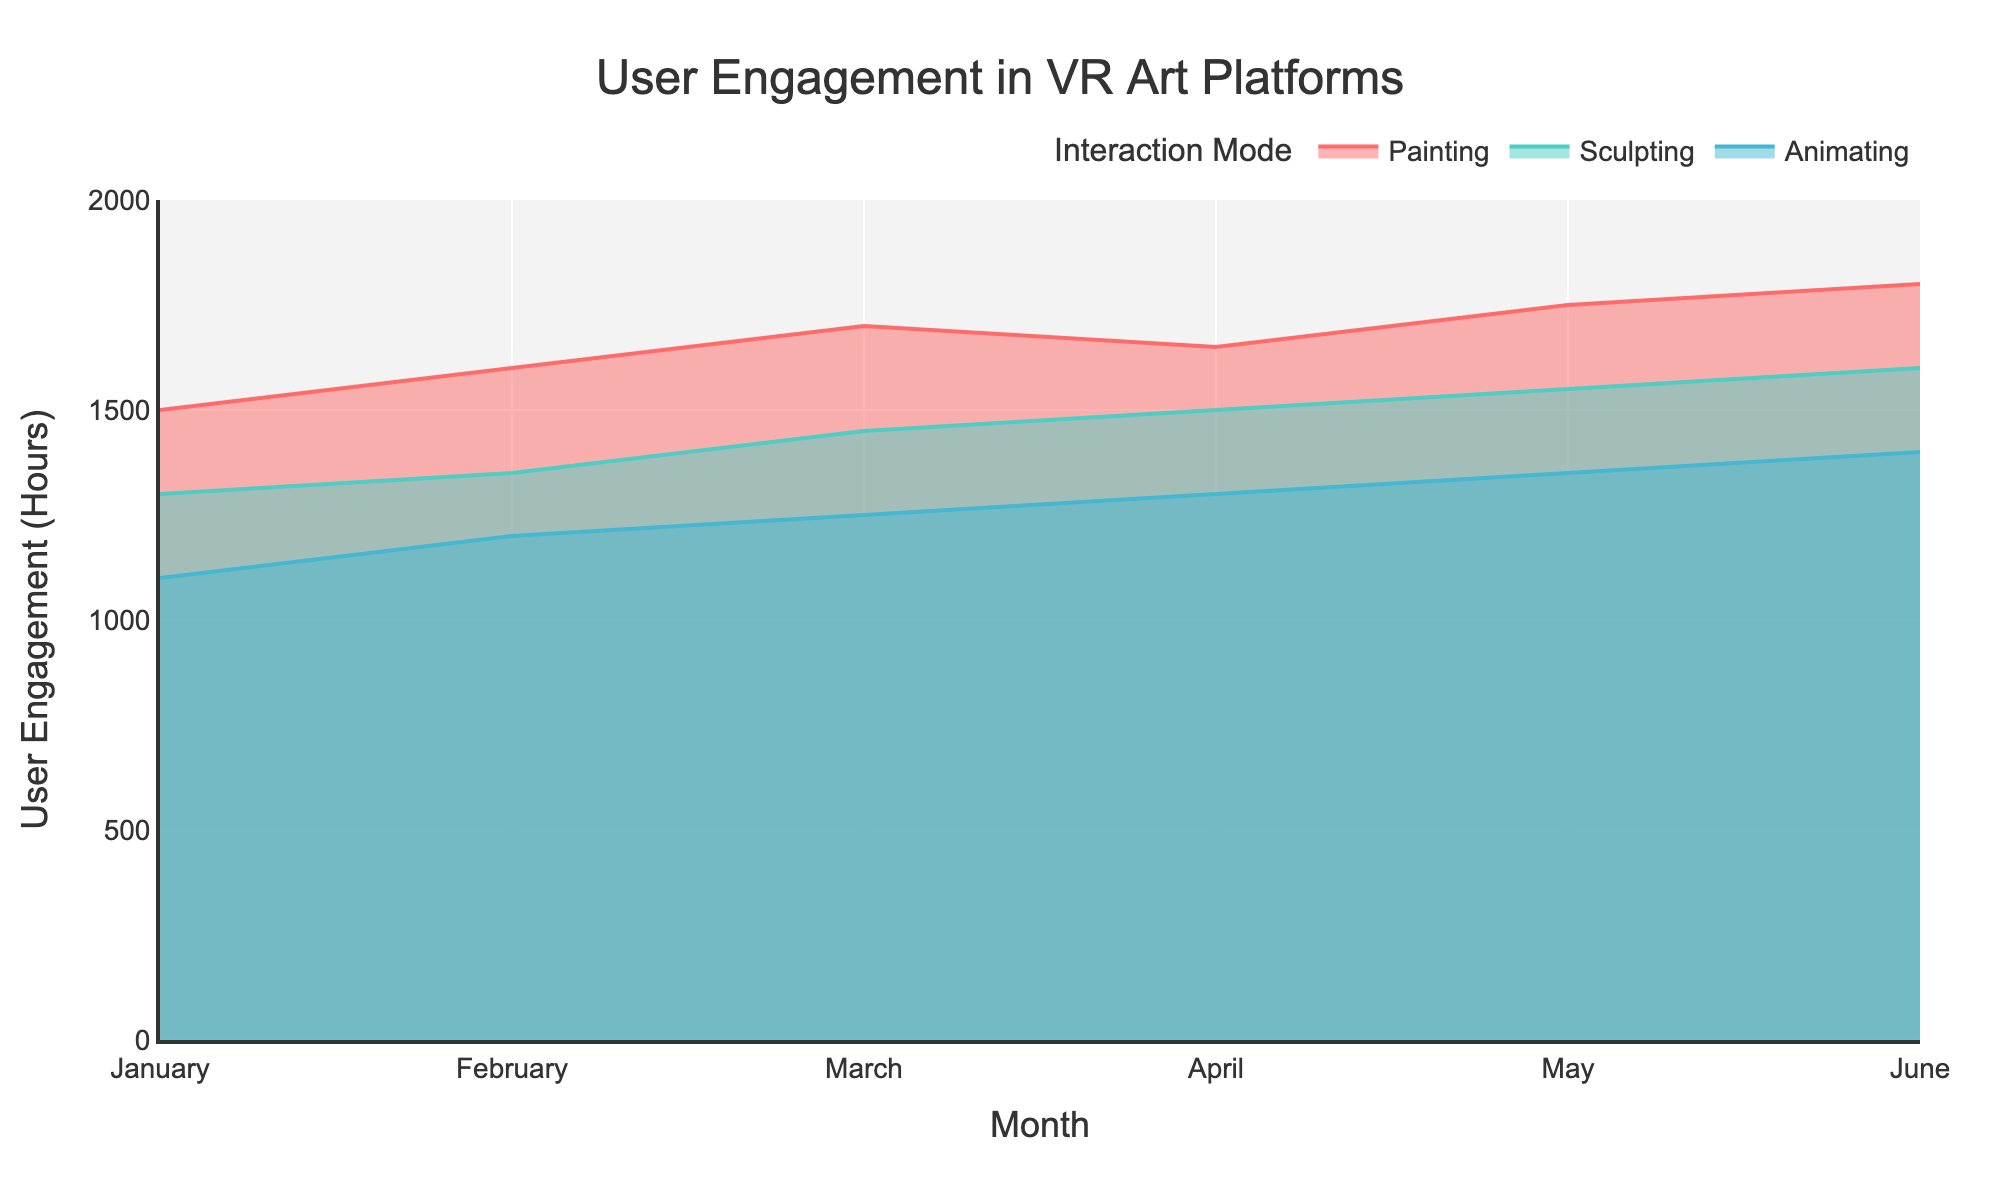What's the title of the chart? The title of the chart is displayed at the top and reads "User Engagement in VR Art Platforms".
Answer: User Engagement in VR Art Platforms How does the user engagement in painting change over the months? By observing the area chart, the user engagement in painting starts at 1500 hours in January and increases steadily each month, reaching 1800 hours by June.
Answer: It increases from 1500 hours to 1800 hours In which month is the user engagement in sculpting the highest? By inspecting the sculpting data points, the user engagement is highest in June at 1600 hours.
Answer: June Which interaction mode has the overall lowest user engagement? The interaction mode with the lowest user engagement can be identified by comparing the areas. Animating has the lowest user engagement across all months, starting at 1100 hours in January and reaching up to 1400 hours in June.
Answer: Animating Compare the user engagement between painting and sculpting in April. Which one is higher and by how much? In April, the user engagement for painting is 1650 hours and for sculpting, it is 1500 hours. Painting has 150 more hours of user engagement than sculpting.
Answer: Painting by 150 hours What trend do you notice in animating over the months? The user engagement in animating rises consistently from 1100 hours in January to 1400 hours in June.
Answer: It increases steadily What is the total user engagement for painting across all months? To find the total, sum up the user engagement hours for painting: 1500 + 1600 + 1700 + 1650 + 1750 + 1800. This results in 10000 hours.
Answer: 10000 hours What is the average user engagement in sculpting from January to June? The average is determined by summing the monthly user engagement (1300 + 1350 + 1450 + 1500 + 1550 + 1600) and then dividing by the number of months (6). This results in 8750 / 6 = 1458.33 hours.
Answer: 1458.33 hours 